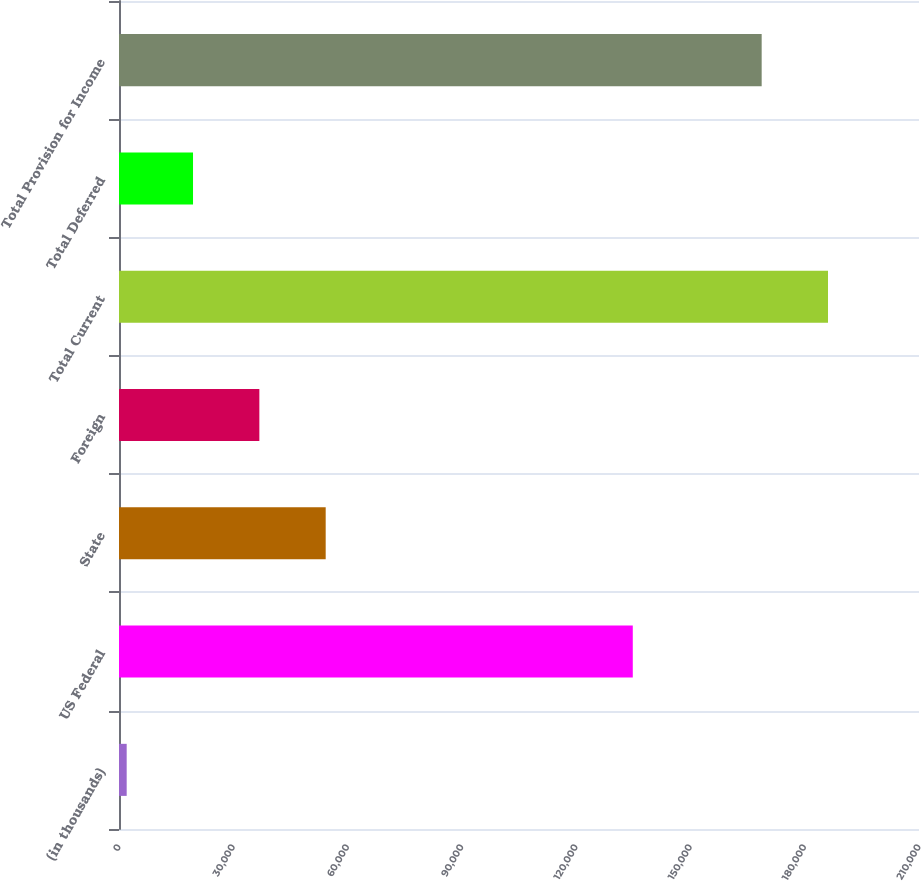Convert chart to OTSL. <chart><loc_0><loc_0><loc_500><loc_500><bar_chart><fcel>(in thousands)<fcel>US Federal<fcel>State<fcel>Foreign<fcel>Total Current<fcel>Total Deferred<fcel>Total Provision for Income<nl><fcel>2018<fcel>134869<fcel>54255.5<fcel>36843<fcel>186114<fcel>19430.5<fcel>168702<nl></chart> 